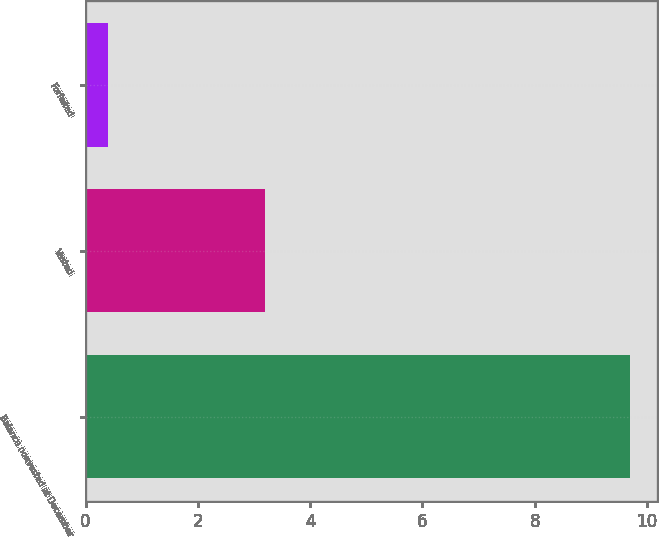Convert chart to OTSL. <chart><loc_0><loc_0><loc_500><loc_500><bar_chart><fcel>Balance nonvested at December<fcel>Vested<fcel>Forfeited<nl><fcel>9.69<fcel>3.2<fcel>0.4<nl></chart> 